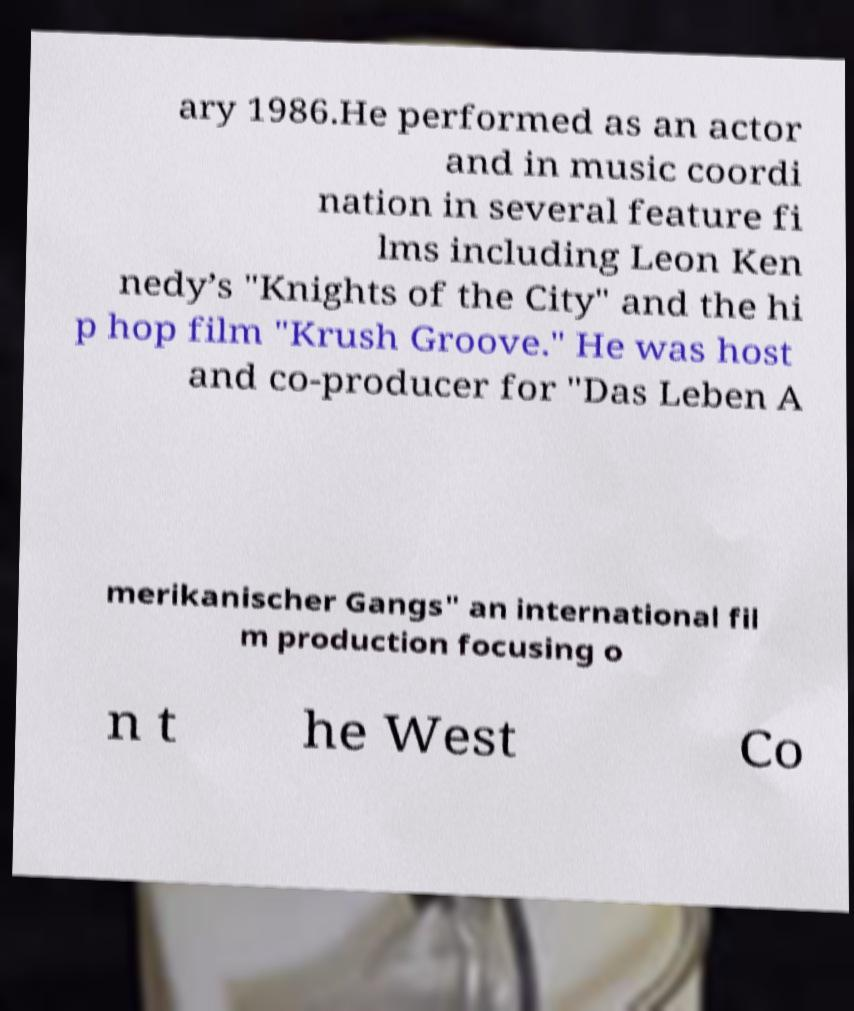There's text embedded in this image that I need extracted. Can you transcribe it verbatim? ary 1986.He performed as an actor and in music coordi nation in several feature fi lms including Leon Ken nedy’s "Knights of the City" and the hi p hop film "Krush Groove." He was host and co-producer for "Das Leben A merikanischer Gangs" an international fil m production focusing o n t he West Co 